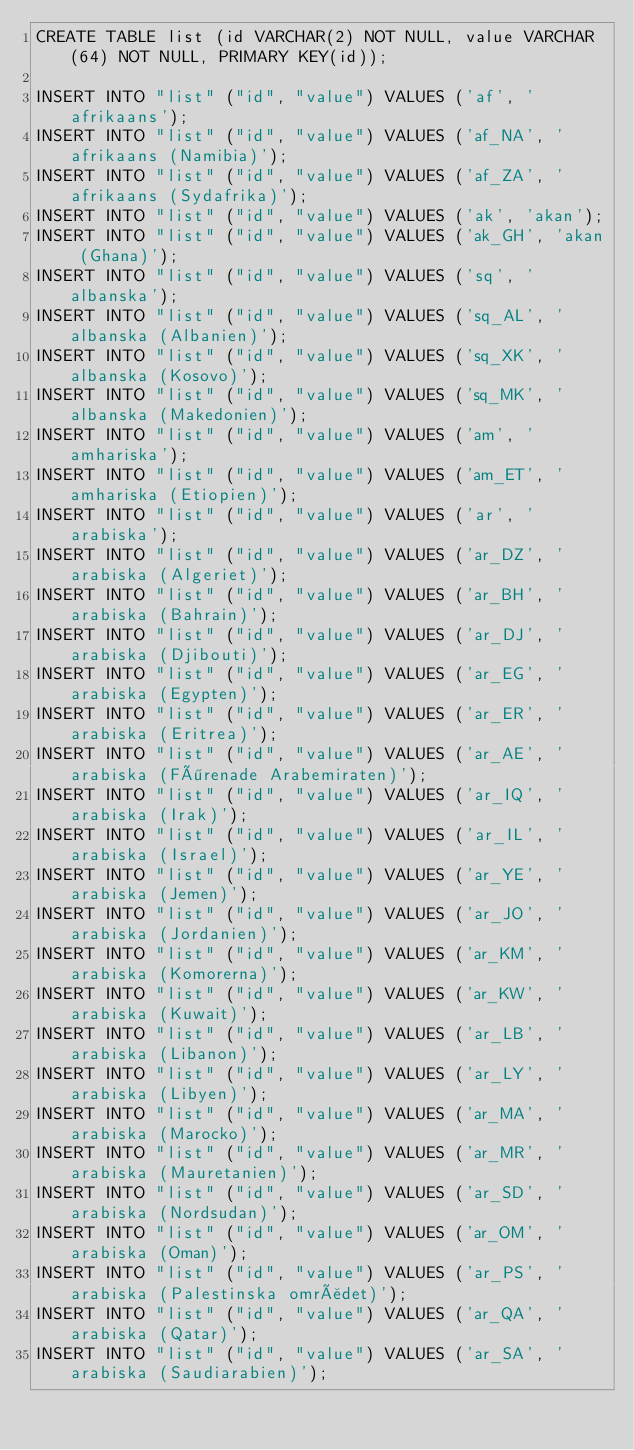Convert code to text. <code><loc_0><loc_0><loc_500><loc_500><_SQL_>CREATE TABLE list (id VARCHAR(2) NOT NULL, value VARCHAR(64) NOT NULL, PRIMARY KEY(id));

INSERT INTO "list" ("id", "value") VALUES ('af', 'afrikaans');
INSERT INTO "list" ("id", "value") VALUES ('af_NA', 'afrikaans (Namibia)');
INSERT INTO "list" ("id", "value") VALUES ('af_ZA', 'afrikaans (Sydafrika)');
INSERT INTO "list" ("id", "value") VALUES ('ak', 'akan');
INSERT INTO "list" ("id", "value") VALUES ('ak_GH', 'akan (Ghana)');
INSERT INTO "list" ("id", "value") VALUES ('sq', 'albanska');
INSERT INTO "list" ("id", "value") VALUES ('sq_AL', 'albanska (Albanien)');
INSERT INTO "list" ("id", "value") VALUES ('sq_XK', 'albanska (Kosovo)');
INSERT INTO "list" ("id", "value") VALUES ('sq_MK', 'albanska (Makedonien)');
INSERT INTO "list" ("id", "value") VALUES ('am', 'amhariska');
INSERT INTO "list" ("id", "value") VALUES ('am_ET', 'amhariska (Etiopien)');
INSERT INTO "list" ("id", "value") VALUES ('ar', 'arabiska');
INSERT INTO "list" ("id", "value") VALUES ('ar_DZ', 'arabiska (Algeriet)');
INSERT INTO "list" ("id", "value") VALUES ('ar_BH', 'arabiska (Bahrain)');
INSERT INTO "list" ("id", "value") VALUES ('ar_DJ', 'arabiska (Djibouti)');
INSERT INTO "list" ("id", "value") VALUES ('ar_EG', 'arabiska (Egypten)');
INSERT INTO "list" ("id", "value") VALUES ('ar_ER', 'arabiska (Eritrea)');
INSERT INTO "list" ("id", "value") VALUES ('ar_AE', 'arabiska (Förenade Arabemiraten)');
INSERT INTO "list" ("id", "value") VALUES ('ar_IQ', 'arabiska (Irak)');
INSERT INTO "list" ("id", "value") VALUES ('ar_IL', 'arabiska (Israel)');
INSERT INTO "list" ("id", "value") VALUES ('ar_YE', 'arabiska (Jemen)');
INSERT INTO "list" ("id", "value") VALUES ('ar_JO', 'arabiska (Jordanien)');
INSERT INTO "list" ("id", "value") VALUES ('ar_KM', 'arabiska (Komorerna)');
INSERT INTO "list" ("id", "value") VALUES ('ar_KW', 'arabiska (Kuwait)');
INSERT INTO "list" ("id", "value") VALUES ('ar_LB', 'arabiska (Libanon)');
INSERT INTO "list" ("id", "value") VALUES ('ar_LY', 'arabiska (Libyen)');
INSERT INTO "list" ("id", "value") VALUES ('ar_MA', 'arabiska (Marocko)');
INSERT INTO "list" ("id", "value") VALUES ('ar_MR', 'arabiska (Mauretanien)');
INSERT INTO "list" ("id", "value") VALUES ('ar_SD', 'arabiska (Nordsudan)');
INSERT INTO "list" ("id", "value") VALUES ('ar_OM', 'arabiska (Oman)');
INSERT INTO "list" ("id", "value") VALUES ('ar_PS', 'arabiska (Palestinska området)');
INSERT INTO "list" ("id", "value") VALUES ('ar_QA', 'arabiska (Qatar)');
INSERT INTO "list" ("id", "value") VALUES ('ar_SA', 'arabiska (Saudiarabien)');</code> 